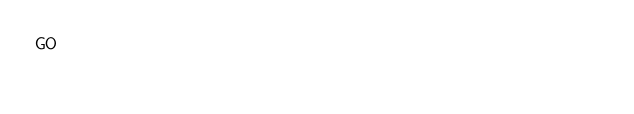<code> <loc_0><loc_0><loc_500><loc_500><_SQL_>GO</code> 